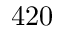<formula> <loc_0><loc_0><loc_500><loc_500>4 2 0</formula> 